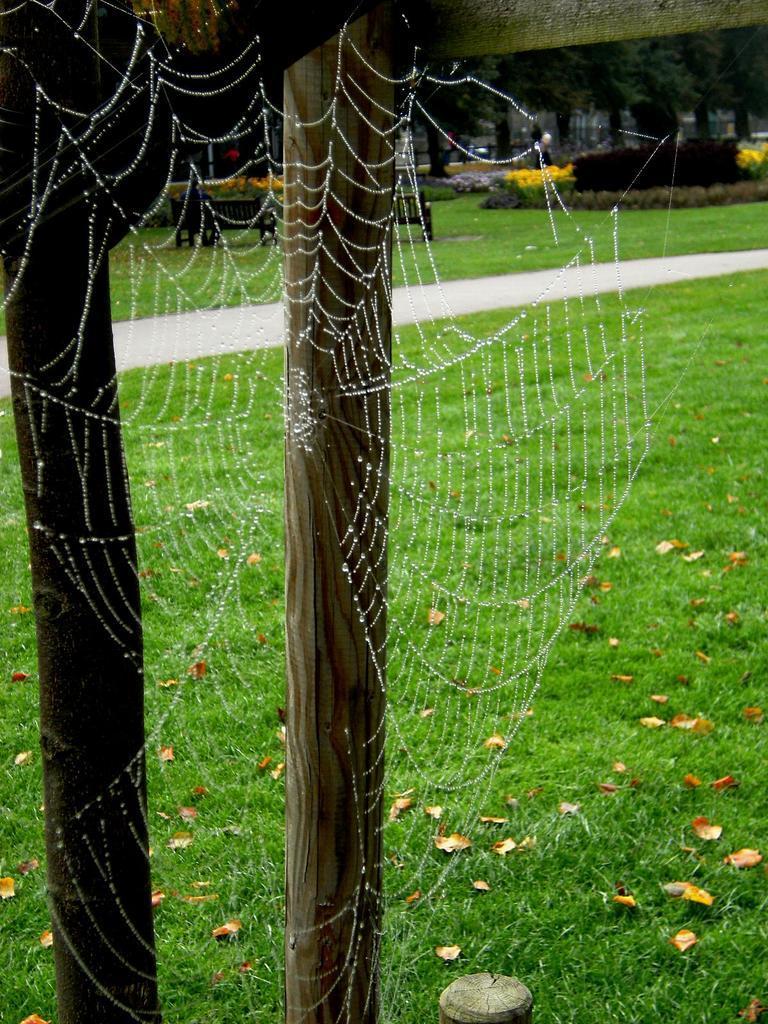Describe this image in one or two sentences. In this image, I can see a spider web, wooden poles, pathway and grass. In the background, I can see benches, plants with flowers and trees. 